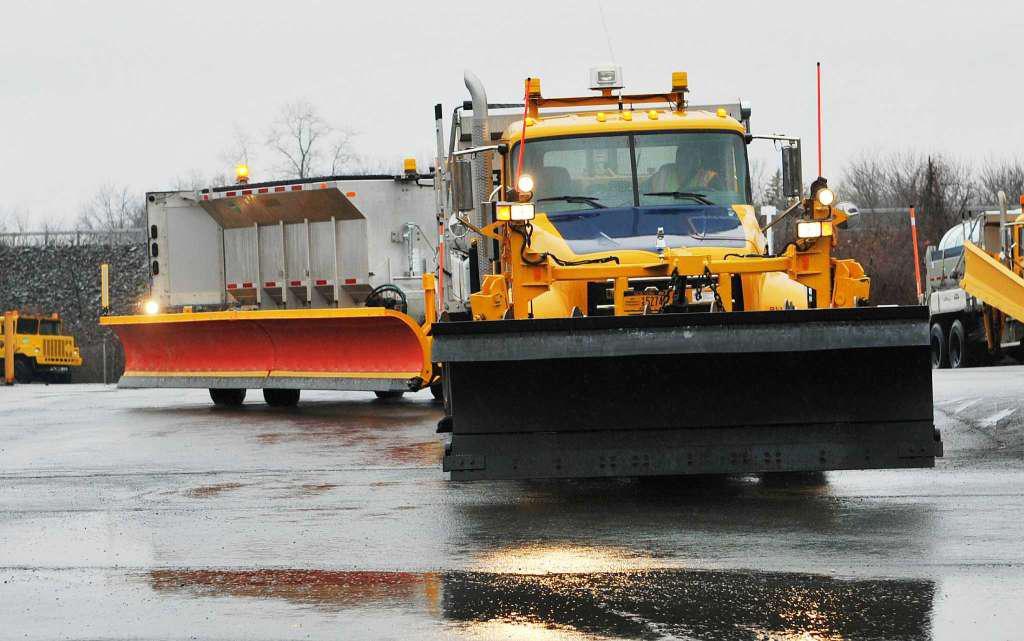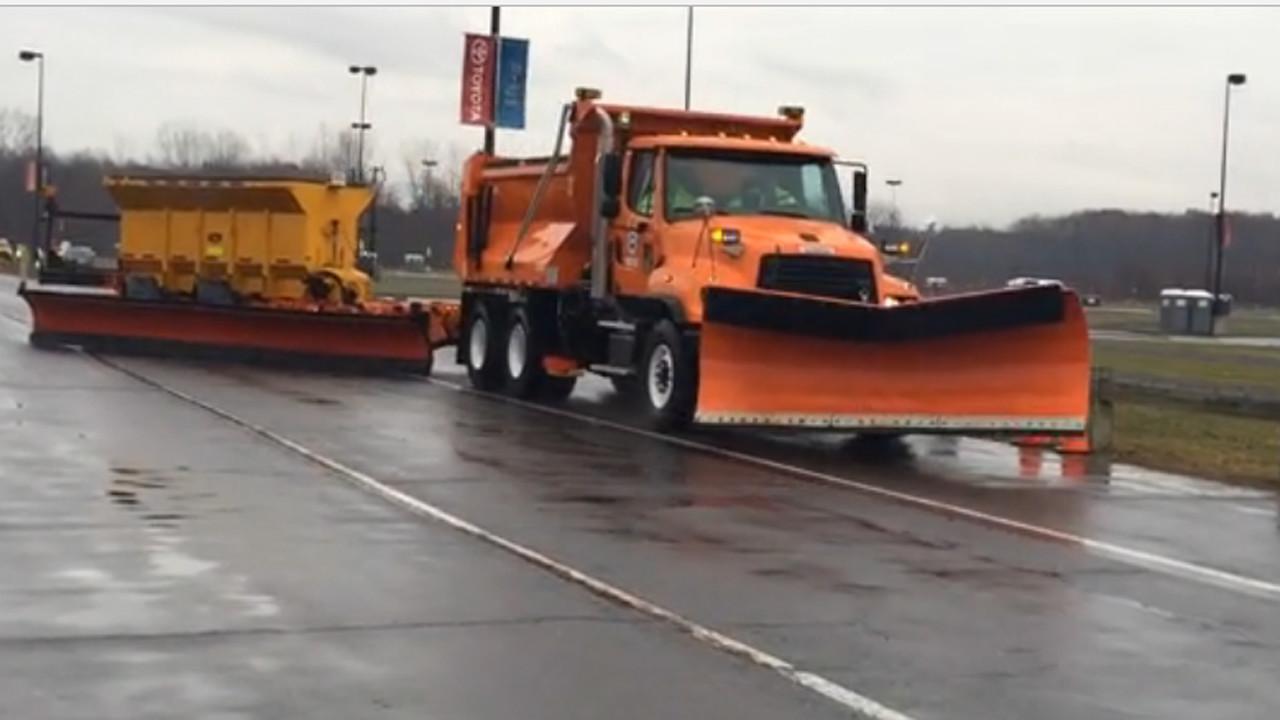The first image is the image on the left, the second image is the image on the right. For the images shown, is this caption "In one image the truck towing a second blade and salt bin has a yellow cab and gray body." true? Answer yes or no. Yes. The first image is the image on the left, the second image is the image on the right. Given the left and right images, does the statement "There are snow scrapers attached to the right hand side of the truck pointing right with no snow on the ground." hold true? Answer yes or no. No. 